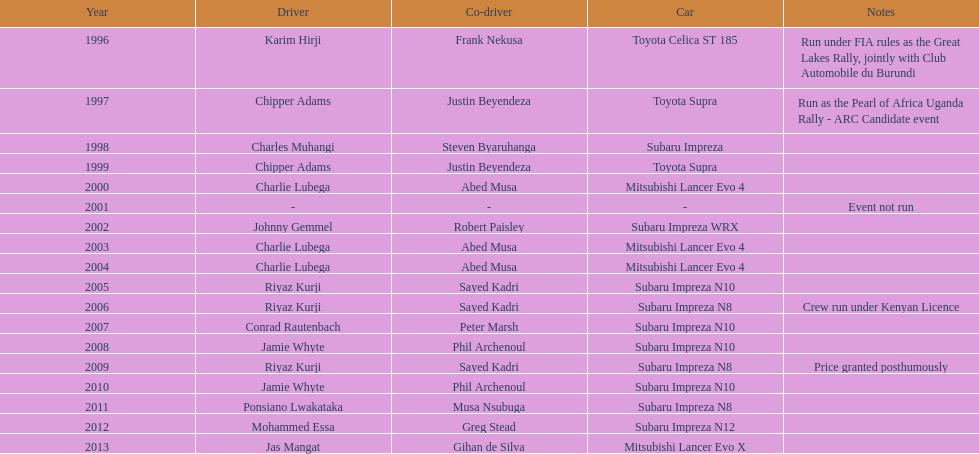Give me the full table as a dictionary. {'header': ['Year', 'Driver', 'Co-driver', 'Car', 'Notes'], 'rows': [['1996', 'Karim Hirji', 'Frank Nekusa', 'Toyota Celica ST 185', 'Run under FIA rules as the Great Lakes Rally, jointly with Club Automobile du Burundi'], ['1997', 'Chipper Adams', 'Justin Beyendeza', 'Toyota Supra', 'Run as the Pearl of Africa Uganda Rally - ARC Candidate event'], ['1998', 'Charles Muhangi', 'Steven Byaruhanga', 'Subaru Impreza', ''], ['1999', 'Chipper Adams', 'Justin Beyendeza', 'Toyota Supra', ''], ['2000', 'Charlie Lubega', 'Abed Musa', 'Mitsubishi Lancer Evo 4', ''], ['2001', '-', '-', '-', 'Event not run'], ['2002', 'Johnny Gemmel', 'Robert Paisley', 'Subaru Impreza WRX', ''], ['2003', 'Charlie Lubega', 'Abed Musa', 'Mitsubishi Lancer Evo 4', ''], ['2004', 'Charlie Lubega', 'Abed Musa', 'Mitsubishi Lancer Evo 4', ''], ['2005', 'Riyaz Kurji', 'Sayed Kadri', 'Subaru Impreza N10', ''], ['2006', 'Riyaz Kurji', 'Sayed Kadri', 'Subaru Impreza N8', 'Crew run under Kenyan Licence'], ['2007', 'Conrad Rautenbach', 'Peter Marsh', 'Subaru Impreza N10', ''], ['2008', 'Jamie Whyte', 'Phil Archenoul', 'Subaru Impreza N10', ''], ['2009', 'Riyaz Kurji', 'Sayed Kadri', 'Subaru Impreza N8', 'Price granted posthumously'], ['2010', 'Jamie Whyte', 'Phil Archenoul', 'Subaru Impreza N10', ''], ['2011', 'Ponsiano Lwakataka', 'Musa Nsubuga', 'Subaru Impreza N8', ''], ['2012', 'Mohammed Essa', 'Greg Stead', 'Subaru Impreza N12', ''], ['2013', 'Jas Mangat', 'Gihan de Silva', 'Mitsubishi Lancer Evo X', '']]} Who is the only driver to have consecutive wins? Charlie Lubega. 